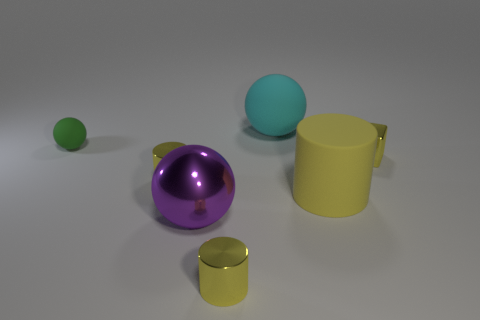There is a large rubber object that is the same color as the shiny block; what is its shape?
Offer a terse response. Cylinder. How many cyan spheres are the same size as the green rubber ball?
Your answer should be very brief. 0. There is a green thing that is made of the same material as the large cylinder; what is its shape?
Provide a short and direct response. Sphere. Are there any large shiny things that have the same color as the big rubber cylinder?
Make the answer very short. No. What is the material of the big purple thing?
Your response must be concise. Metal. What number of objects are gray matte cylinders or tiny rubber objects?
Keep it short and to the point. 1. There is a sphere in front of the tiny green matte sphere; how big is it?
Ensure brevity in your answer.  Large. What number of other things are there of the same material as the small ball
Offer a very short reply. 2. There is a matte ball in front of the large rubber ball; is there a matte object that is on the left side of it?
Provide a succinct answer. No. Is there anything else that is the same shape as the big yellow matte object?
Ensure brevity in your answer.  Yes. 